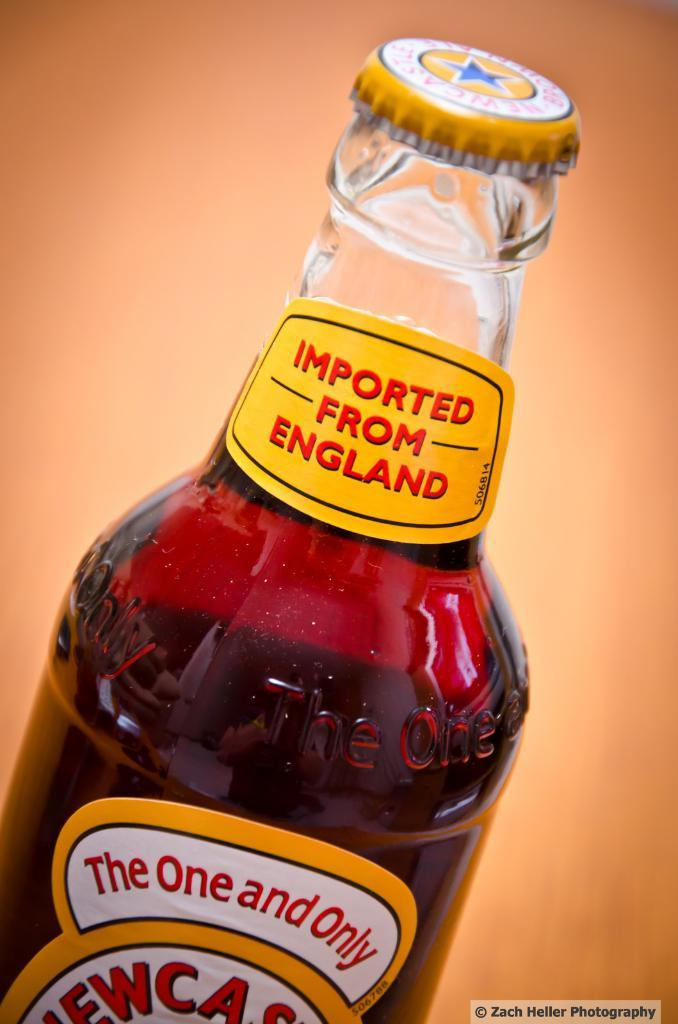What is inside the bottle that is visible in the image? The bottle contains red-colored liquid. What is the appearance of the bottle in the image? The bottle has a cap. Where was the bottle manufactured? The bottle is imported from England. What type of spoon is used to stir the liquid in the bottle? There is no spoon present in the image, and the bottle is sealed with a cap, so stirring the liquid is not possible. 